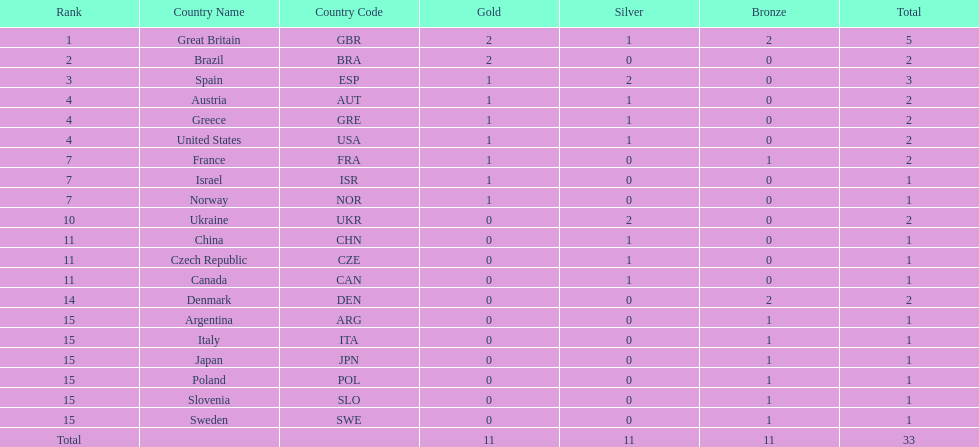How many medals did each country receive? 5, 2, 3, 2, 2, 2, 2, 1, 1, 2, 1, 1, 1, 2, 1, 1, 1, 1, 1, 1. Which country received 3 medals? Spain (ESP). 